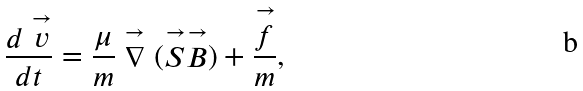<formula> <loc_0><loc_0><loc_500><loc_500>\frac { d \stackrel { \rightarrow } { v } } { d t } = \frac { \mu } { m } \stackrel { \rightarrow } { \nabla } ( \stackrel { \rightarrow } { S } \stackrel { \rightarrow } { B } ) + \frac { \stackrel { \rightarrow } { f } } { m } ,</formula> 